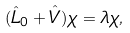Convert formula to latex. <formula><loc_0><loc_0><loc_500><loc_500>( \hat { L } _ { 0 } + \hat { V } ) \chi = \lambda \chi ,</formula> 